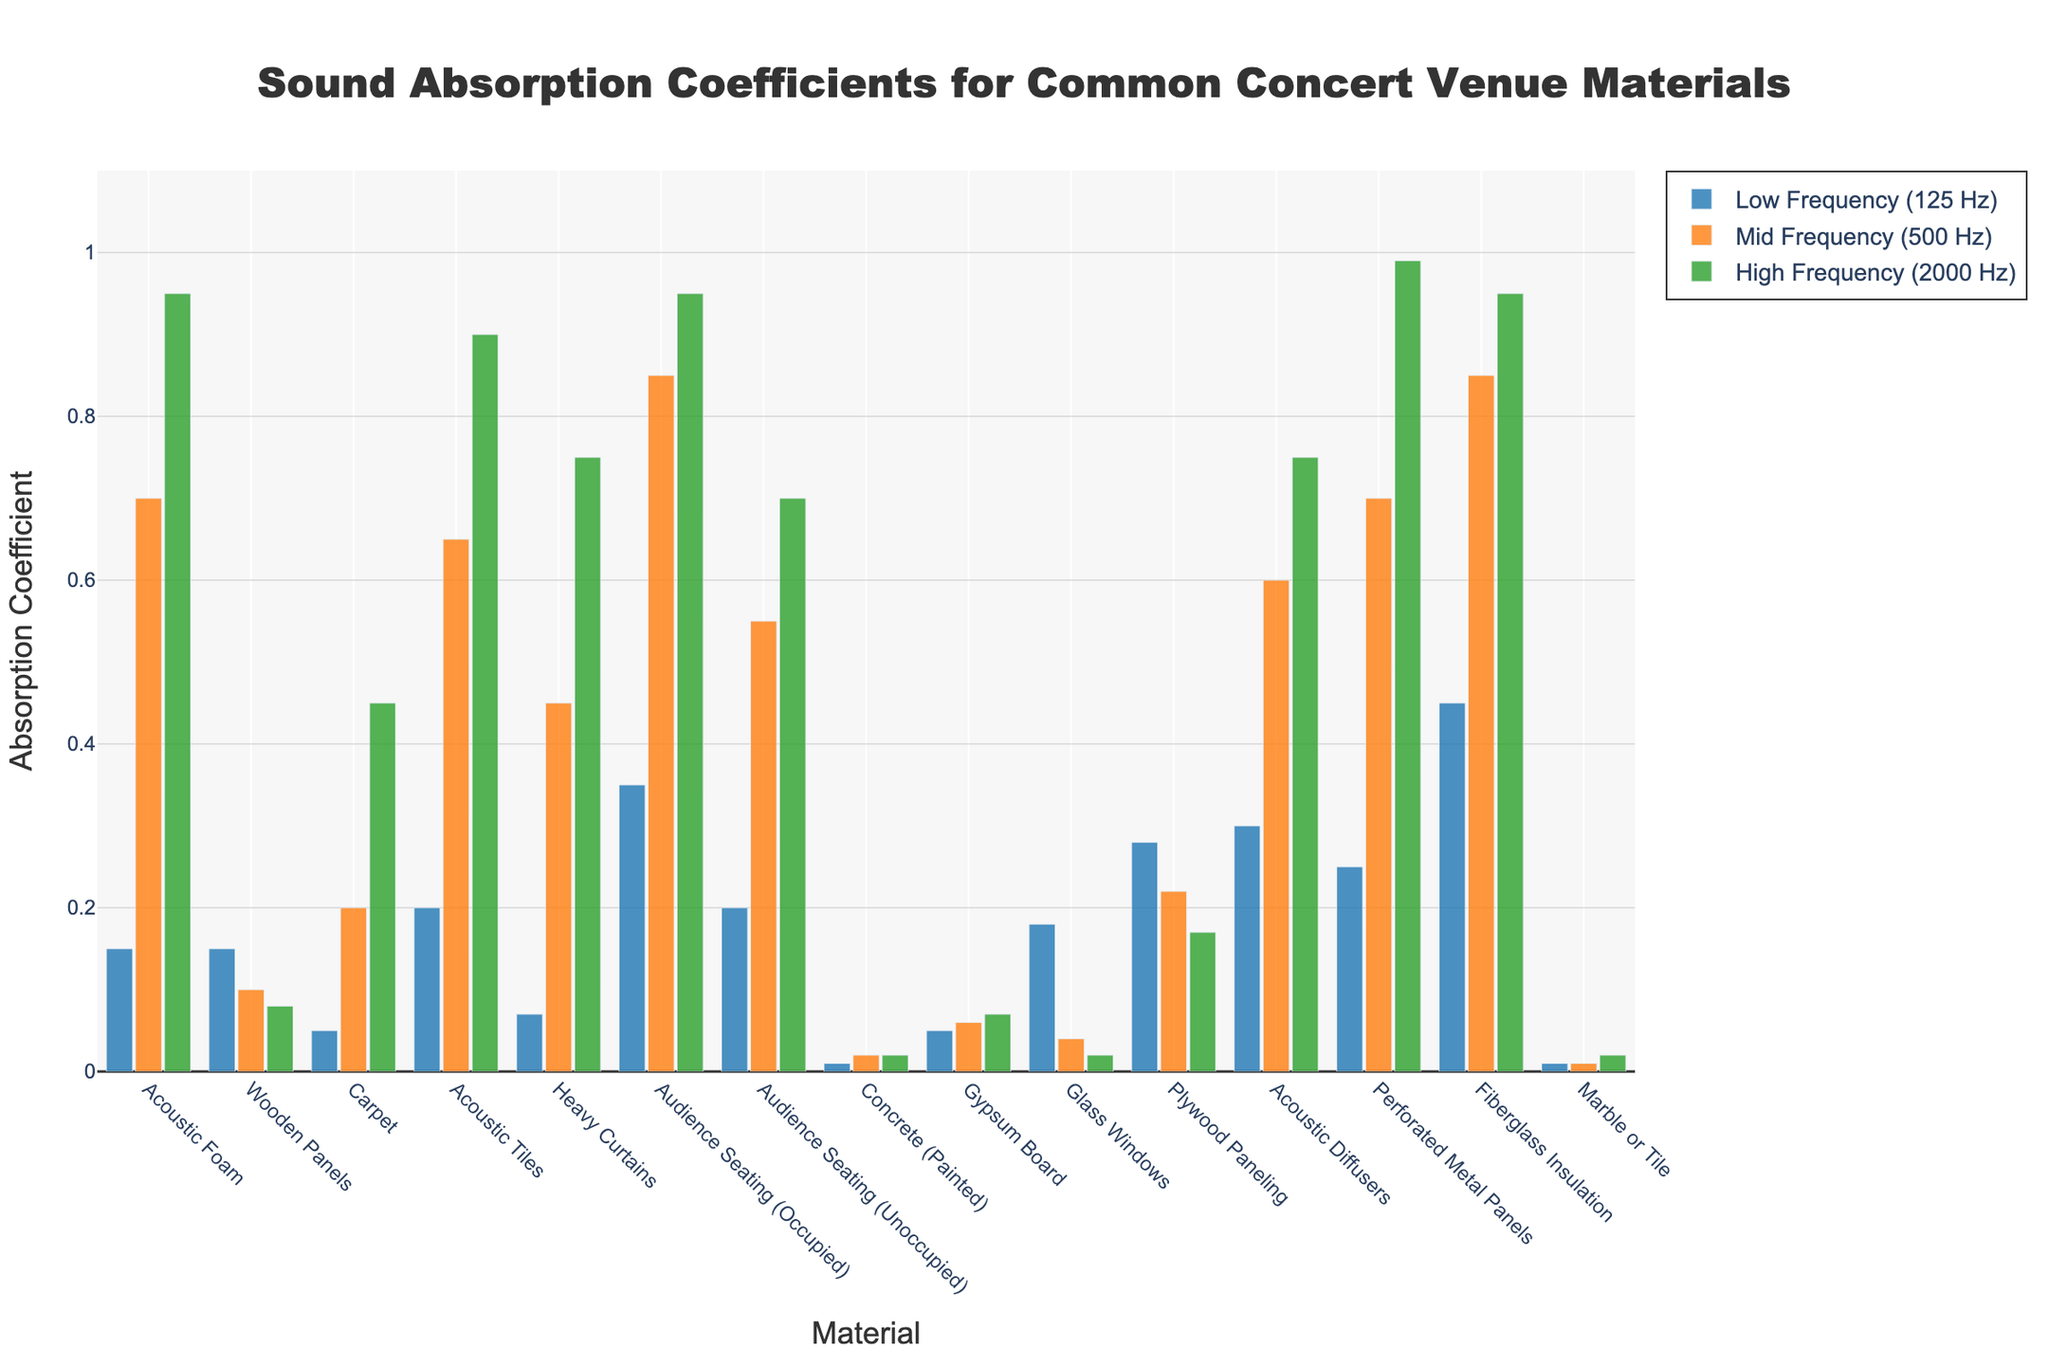Which material has the highest absorption coefficient at high frequency (2000 Hz)? Look at the green bars in the chart and identify the tallest one representing the absorption coefficients at high frequency (2000 Hz). The Perforated Metal Panels have the highest bar.
Answer: Perforated Metal Panels Which material has the lowest absorption coefficient at mid frequency (500 Hz)? Examine the heights of the orange bars representing mid-frequency values. Marble or Tile has the lowest absorption coefficient at mid frequency (500 Hz).
Answer: Marble or Tile What is the average absorption coefficient of the Wooden Panels across all frequencies? Add the absorption coefficients for Wooden Panels (0.15 + 0.10 + 0.08) and divide by 3 to find the average. The sum is 0.33, and the average is 0.33 / 3.
Answer: 0.11 Which two materials have the same absorption coefficient at low frequency (125 Hz)? Identify the materials that have the same bar height in the blue section representing low frequency. Acoustic Foam and Wooden Panels both have an absorption coefficient of 0.15 at low frequency.
Answer: Acoustic Foam and Wooden Panels Is the absorption coefficient of Gypsum Board at low frequency higher or lower than that of Carpet at the same frequency? Compare the heights of the blue bars for Gypsum Board and Carpet. Gypsum Board has a higher absorption coefficient (0.05) than Carpet (0.05) at low frequency.
Answer: Equal Which materials have absorption coefficients greater than 0.8 at high frequency (2000 Hz)? Look for green bars with heights greater than 0.8 and note their materials. Acoustic Foam, Acoustic Tiles, Audience Seating (Occupied), Fiberglass Insulation, and Perforated Metal Panels have absorption coefficients greater than 0.8 at high frequency.
Answer: Acoustic Foam, Acoustic Tiles, Audience Seating (Occupied), Fiberglass Insulation, Perforated Metal Panels How does the absorption coefficient of Glass Windows at low frequency compare to that at high frequency? Compare the heights of the blue and green bars for Glass Windows. The low-frequency absorption coefficient (0.18) is higher than the high-frequency absorption coefficient (0.02).
Answer: Higher at low frequency What is the difference in the absorption coefficient at mid frequency between Acoustic Foam and Concrete (Painted)? Subtract the mid-frequency absorption coefficient of Concrete (Painted) from that of Acoustic Foam (0.70 - 0.02). The result is 0.68.
Answer: 0.68 Of the materials listed, which one has the most balanced absorption coefficients across all frequencies? Look for the material with similar bar heights across blue, orange, and green. Audience Seating (Occupied) has absorption coefficients (0.35, 0.85, 0.95), showing some variance but still relatively balanced. Audience Seating (Unoccupied) is more balanced (0.20, 0.55, 0.70).
Answer: Audience Seating (Unoccupied) 